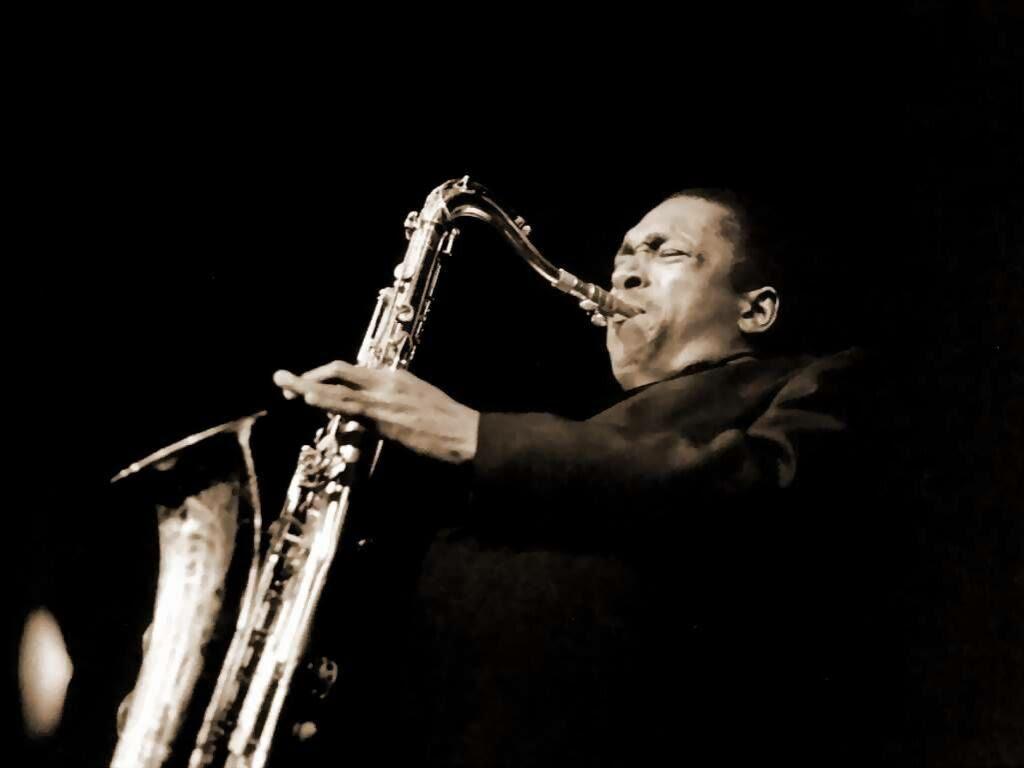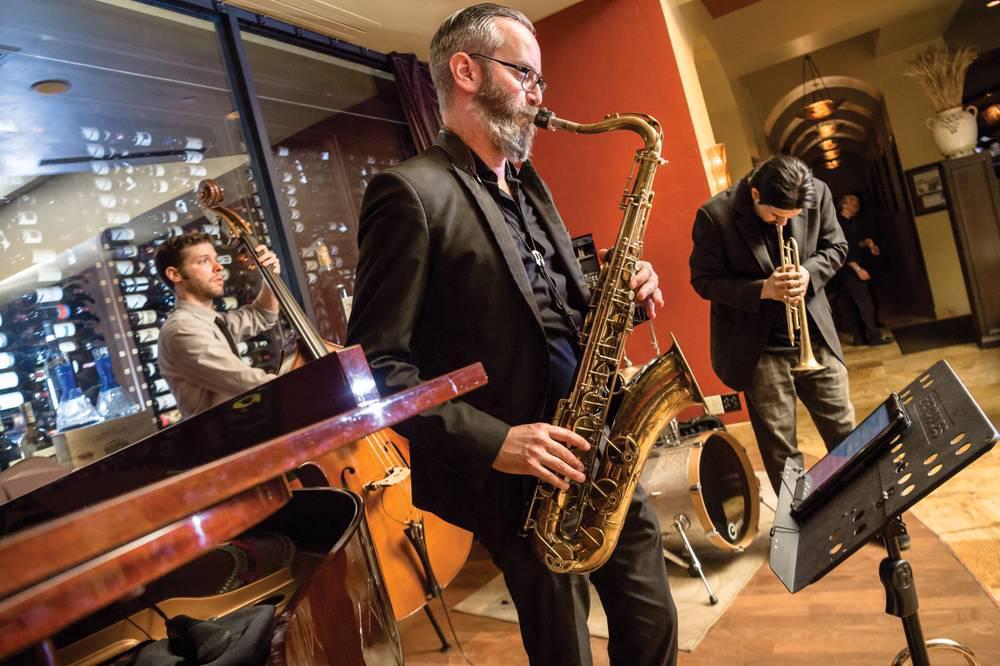The first image is the image on the left, the second image is the image on the right. For the images displayed, is the sentence "One image shows a saxophone held by a dark-skinned man in a suit, and the other image shows someone with long hair holding a saxophone in front of a flight of stairs." factually correct? Answer yes or no. No. The first image is the image on the left, the second image is the image on the right. Assess this claim about the two images: "Every single person's elbow is clothed.". Correct or not? Answer yes or no. Yes. 